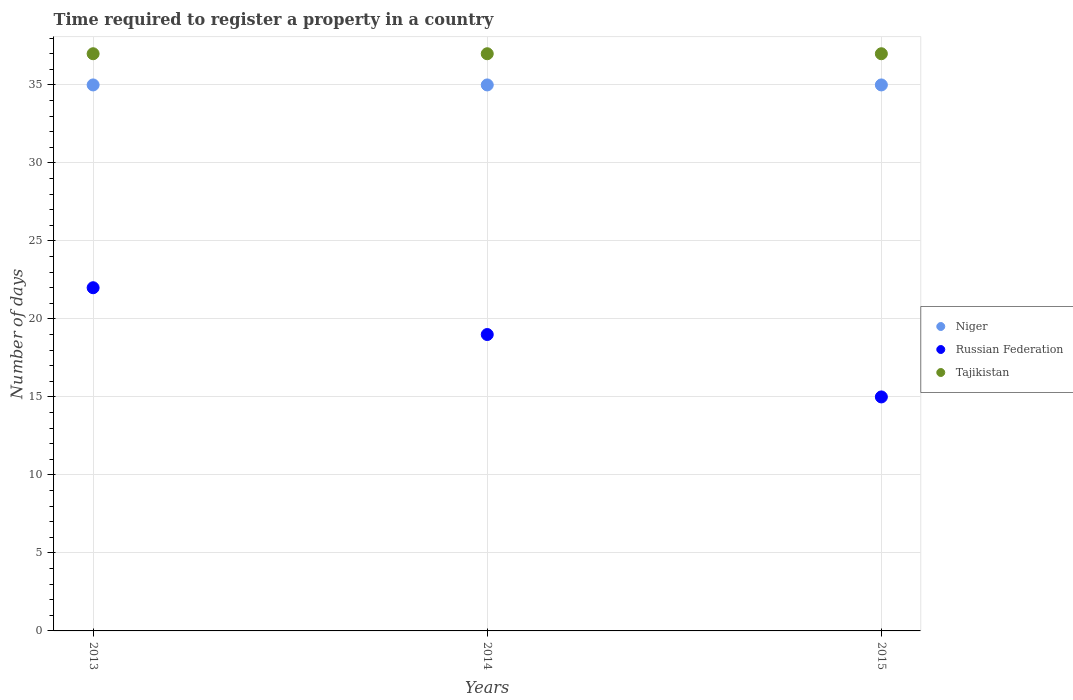How many different coloured dotlines are there?
Provide a short and direct response. 3. Is the number of dotlines equal to the number of legend labels?
Your answer should be compact. Yes. What is the number of days required to register a property in Niger in 2014?
Offer a very short reply. 35. Across all years, what is the maximum number of days required to register a property in Tajikistan?
Your answer should be compact. 37. Across all years, what is the minimum number of days required to register a property in Niger?
Provide a succinct answer. 35. What is the difference between the number of days required to register a property in Russian Federation in 2014 and that in 2015?
Provide a succinct answer. 4. In the year 2015, what is the difference between the number of days required to register a property in Russian Federation and number of days required to register a property in Tajikistan?
Your answer should be compact. -22. In how many years, is the number of days required to register a property in Niger greater than 4 days?
Keep it short and to the point. 3. What is the ratio of the number of days required to register a property in Russian Federation in 2013 to that in 2014?
Your response must be concise. 1.16. Is the number of days required to register a property in Tajikistan in 2013 less than that in 2015?
Make the answer very short. No. Is the sum of the number of days required to register a property in Russian Federation in 2014 and 2015 greater than the maximum number of days required to register a property in Niger across all years?
Offer a very short reply. No. Is it the case that in every year, the sum of the number of days required to register a property in Niger and number of days required to register a property in Tajikistan  is greater than the number of days required to register a property in Russian Federation?
Give a very brief answer. Yes. Is the number of days required to register a property in Russian Federation strictly greater than the number of days required to register a property in Niger over the years?
Offer a very short reply. No. Is the number of days required to register a property in Tajikistan strictly less than the number of days required to register a property in Russian Federation over the years?
Provide a succinct answer. No. How many dotlines are there?
Provide a succinct answer. 3. How many years are there in the graph?
Your response must be concise. 3. What is the difference between two consecutive major ticks on the Y-axis?
Give a very brief answer. 5. Does the graph contain any zero values?
Ensure brevity in your answer.  No. How many legend labels are there?
Keep it short and to the point. 3. What is the title of the graph?
Provide a succinct answer. Time required to register a property in a country. Does "Honduras" appear as one of the legend labels in the graph?
Provide a succinct answer. No. What is the label or title of the X-axis?
Provide a succinct answer. Years. What is the label or title of the Y-axis?
Make the answer very short. Number of days. What is the Number of days in Niger in 2013?
Your answer should be very brief. 35. What is the Number of days in Russian Federation in 2013?
Make the answer very short. 22. What is the Number of days of Tajikistan in 2013?
Your answer should be compact. 37. What is the Number of days in Niger in 2014?
Offer a very short reply. 35. What is the Number of days in Tajikistan in 2014?
Make the answer very short. 37. What is the Number of days in Russian Federation in 2015?
Offer a very short reply. 15. What is the Number of days of Tajikistan in 2015?
Keep it short and to the point. 37. Across all years, what is the minimum Number of days of Niger?
Your response must be concise. 35. What is the total Number of days in Niger in the graph?
Your answer should be compact. 105. What is the total Number of days of Russian Federation in the graph?
Offer a terse response. 56. What is the total Number of days of Tajikistan in the graph?
Make the answer very short. 111. What is the difference between the Number of days in Niger in 2013 and that in 2015?
Keep it short and to the point. 0. What is the difference between the Number of days in Russian Federation in 2013 and that in 2015?
Ensure brevity in your answer.  7. What is the difference between the Number of days of Tajikistan in 2014 and that in 2015?
Make the answer very short. 0. What is the difference between the Number of days of Niger in 2013 and the Number of days of Tajikistan in 2014?
Provide a short and direct response. -2. What is the difference between the Number of days in Niger in 2013 and the Number of days in Russian Federation in 2015?
Offer a terse response. 20. What is the difference between the Number of days of Niger in 2014 and the Number of days of Tajikistan in 2015?
Provide a short and direct response. -2. What is the average Number of days in Russian Federation per year?
Keep it short and to the point. 18.67. In the year 2014, what is the difference between the Number of days in Niger and Number of days in Russian Federation?
Offer a very short reply. 16. In the year 2015, what is the difference between the Number of days of Niger and Number of days of Tajikistan?
Your answer should be very brief. -2. What is the ratio of the Number of days of Niger in 2013 to that in 2014?
Provide a short and direct response. 1. What is the ratio of the Number of days in Russian Federation in 2013 to that in 2014?
Give a very brief answer. 1.16. What is the ratio of the Number of days in Tajikistan in 2013 to that in 2014?
Make the answer very short. 1. What is the ratio of the Number of days in Niger in 2013 to that in 2015?
Offer a very short reply. 1. What is the ratio of the Number of days of Russian Federation in 2013 to that in 2015?
Your response must be concise. 1.47. What is the ratio of the Number of days of Russian Federation in 2014 to that in 2015?
Offer a very short reply. 1.27. What is the ratio of the Number of days in Tajikistan in 2014 to that in 2015?
Offer a terse response. 1. What is the difference between the highest and the second highest Number of days of Niger?
Your answer should be very brief. 0. What is the difference between the highest and the lowest Number of days of Tajikistan?
Give a very brief answer. 0. 